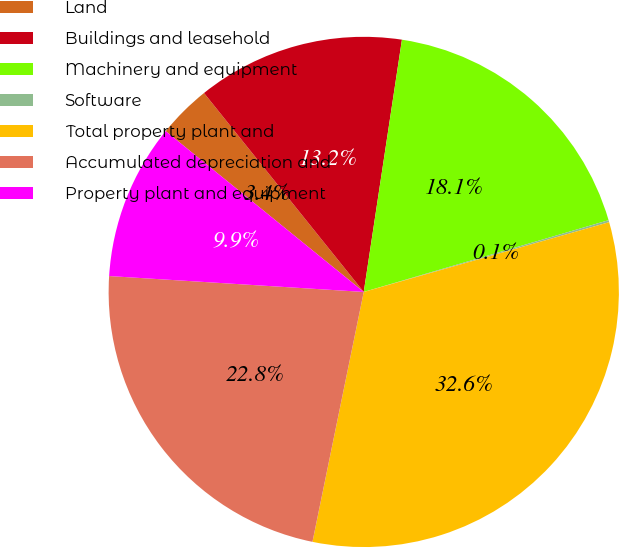Convert chart to OTSL. <chart><loc_0><loc_0><loc_500><loc_500><pie_chart><fcel>Land<fcel>Buildings and leasehold<fcel>Machinery and equipment<fcel>Software<fcel>Total property plant and<fcel>Accumulated depreciation and<fcel>Property plant and equipment<nl><fcel>3.38%<fcel>13.16%<fcel>18.07%<fcel>0.13%<fcel>32.63%<fcel>22.77%<fcel>9.86%<nl></chart> 